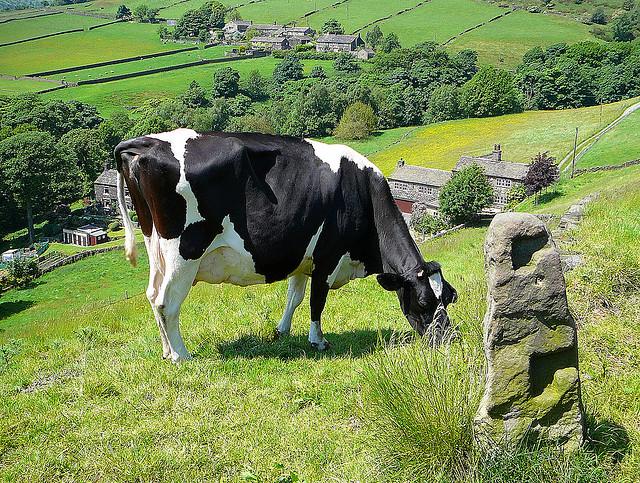What is the weather like in the images?
Give a very brief answer. Sunny. How many trees are there?
Short answer required. 100. What color is the cow?
Keep it brief. Black and white. What animal is this?
Quick response, please. Cow. Are there any trees near this cow?
Keep it brief. No. Is there a fence?
Concise answer only. No. How many animals are in the picture?
Short answer required. 1. Is this cow standing near a stone tower??
Concise answer only. Yes. What is this cow looking at?
Keep it brief. Grass. 